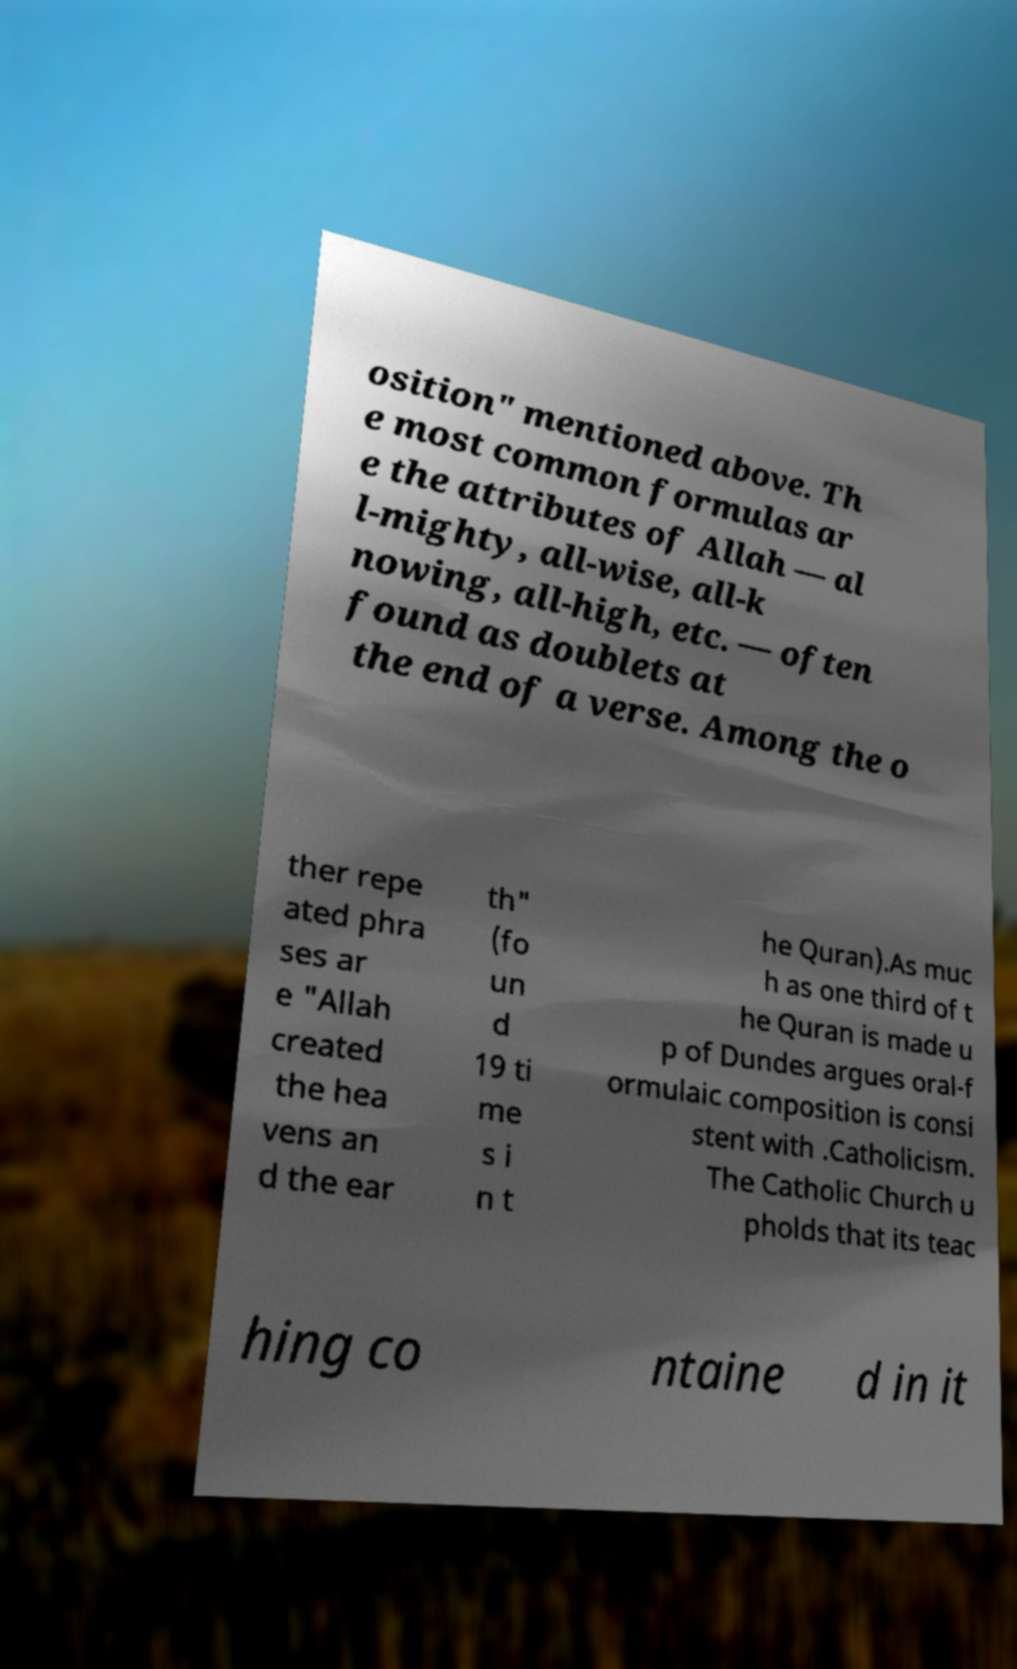Please read and relay the text visible in this image. What does it say? osition" mentioned above. Th e most common formulas ar e the attributes of Allah — al l-mighty, all-wise, all-k nowing, all-high, etc. — often found as doublets at the end of a verse. Among the o ther repe ated phra ses ar e "Allah created the hea vens an d the ear th" (fo un d 19 ti me s i n t he Quran).As muc h as one third of t he Quran is made u p of Dundes argues oral-f ormulaic composition is consi stent with .Catholicism. The Catholic Church u pholds that its teac hing co ntaine d in it 